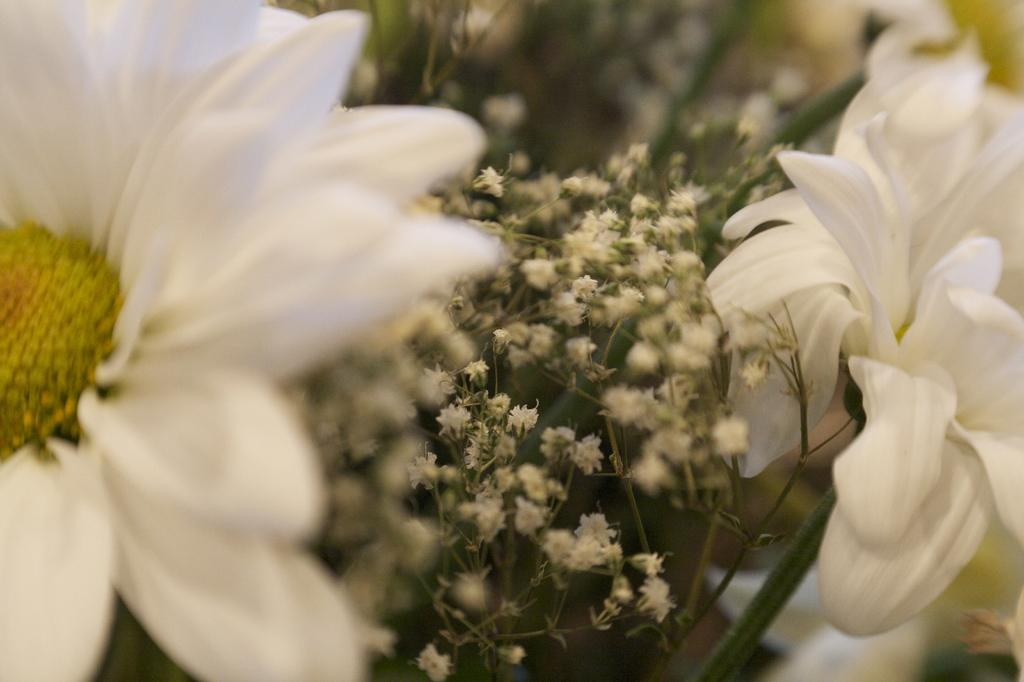What type of flowers can be seen in the image? The image contains white flowers. What else is present in the middle of the image? There are small plants in the middle of the image. What can be observed on the yellow flower in the image? Pollen grains are visible on the yellow flower in the image. What is the color of the pollen grains? The pollen grains are associated with a yellow flower. What type of heart can be seen in the image? There is no heart present in the image; it features white flowers, small plants, and a yellow flower with pollen grains. How can we sort the flowers in the image based on their color? The flowers in the image cannot be sorted based on their color, as there is only one color mentioned, which is white. 